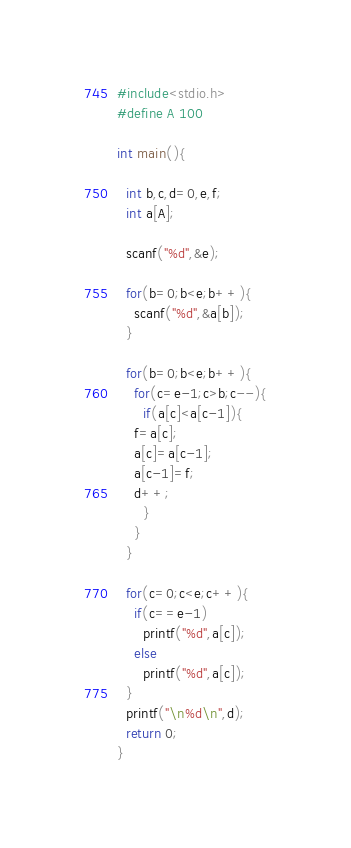<code> <loc_0><loc_0><loc_500><loc_500><_C_>#include<stdio.h>
#define A 100

int main(){

  int b,c,d=0,e,f;
  int a[A];

  scanf("%d",&e);

  for(b=0;b<e;b++){
    scanf("%d",&a[b]);
  }

  for(b=0;b<e;b++){
    for(c=e-1;c>b;c--){
      if(a[c]<a[c-1]){
	f=a[c];
	a[c]=a[c-1];
	a[c-1]=f;
	d++;
      }
    }
  }

  for(c=0;c<e;c++){
    if(c==e-1)
      printf("%d",a[c]);
    else
      printf("%d",a[c]);
  }
  printf("\n%d\n",d);
  return 0;
}</code> 